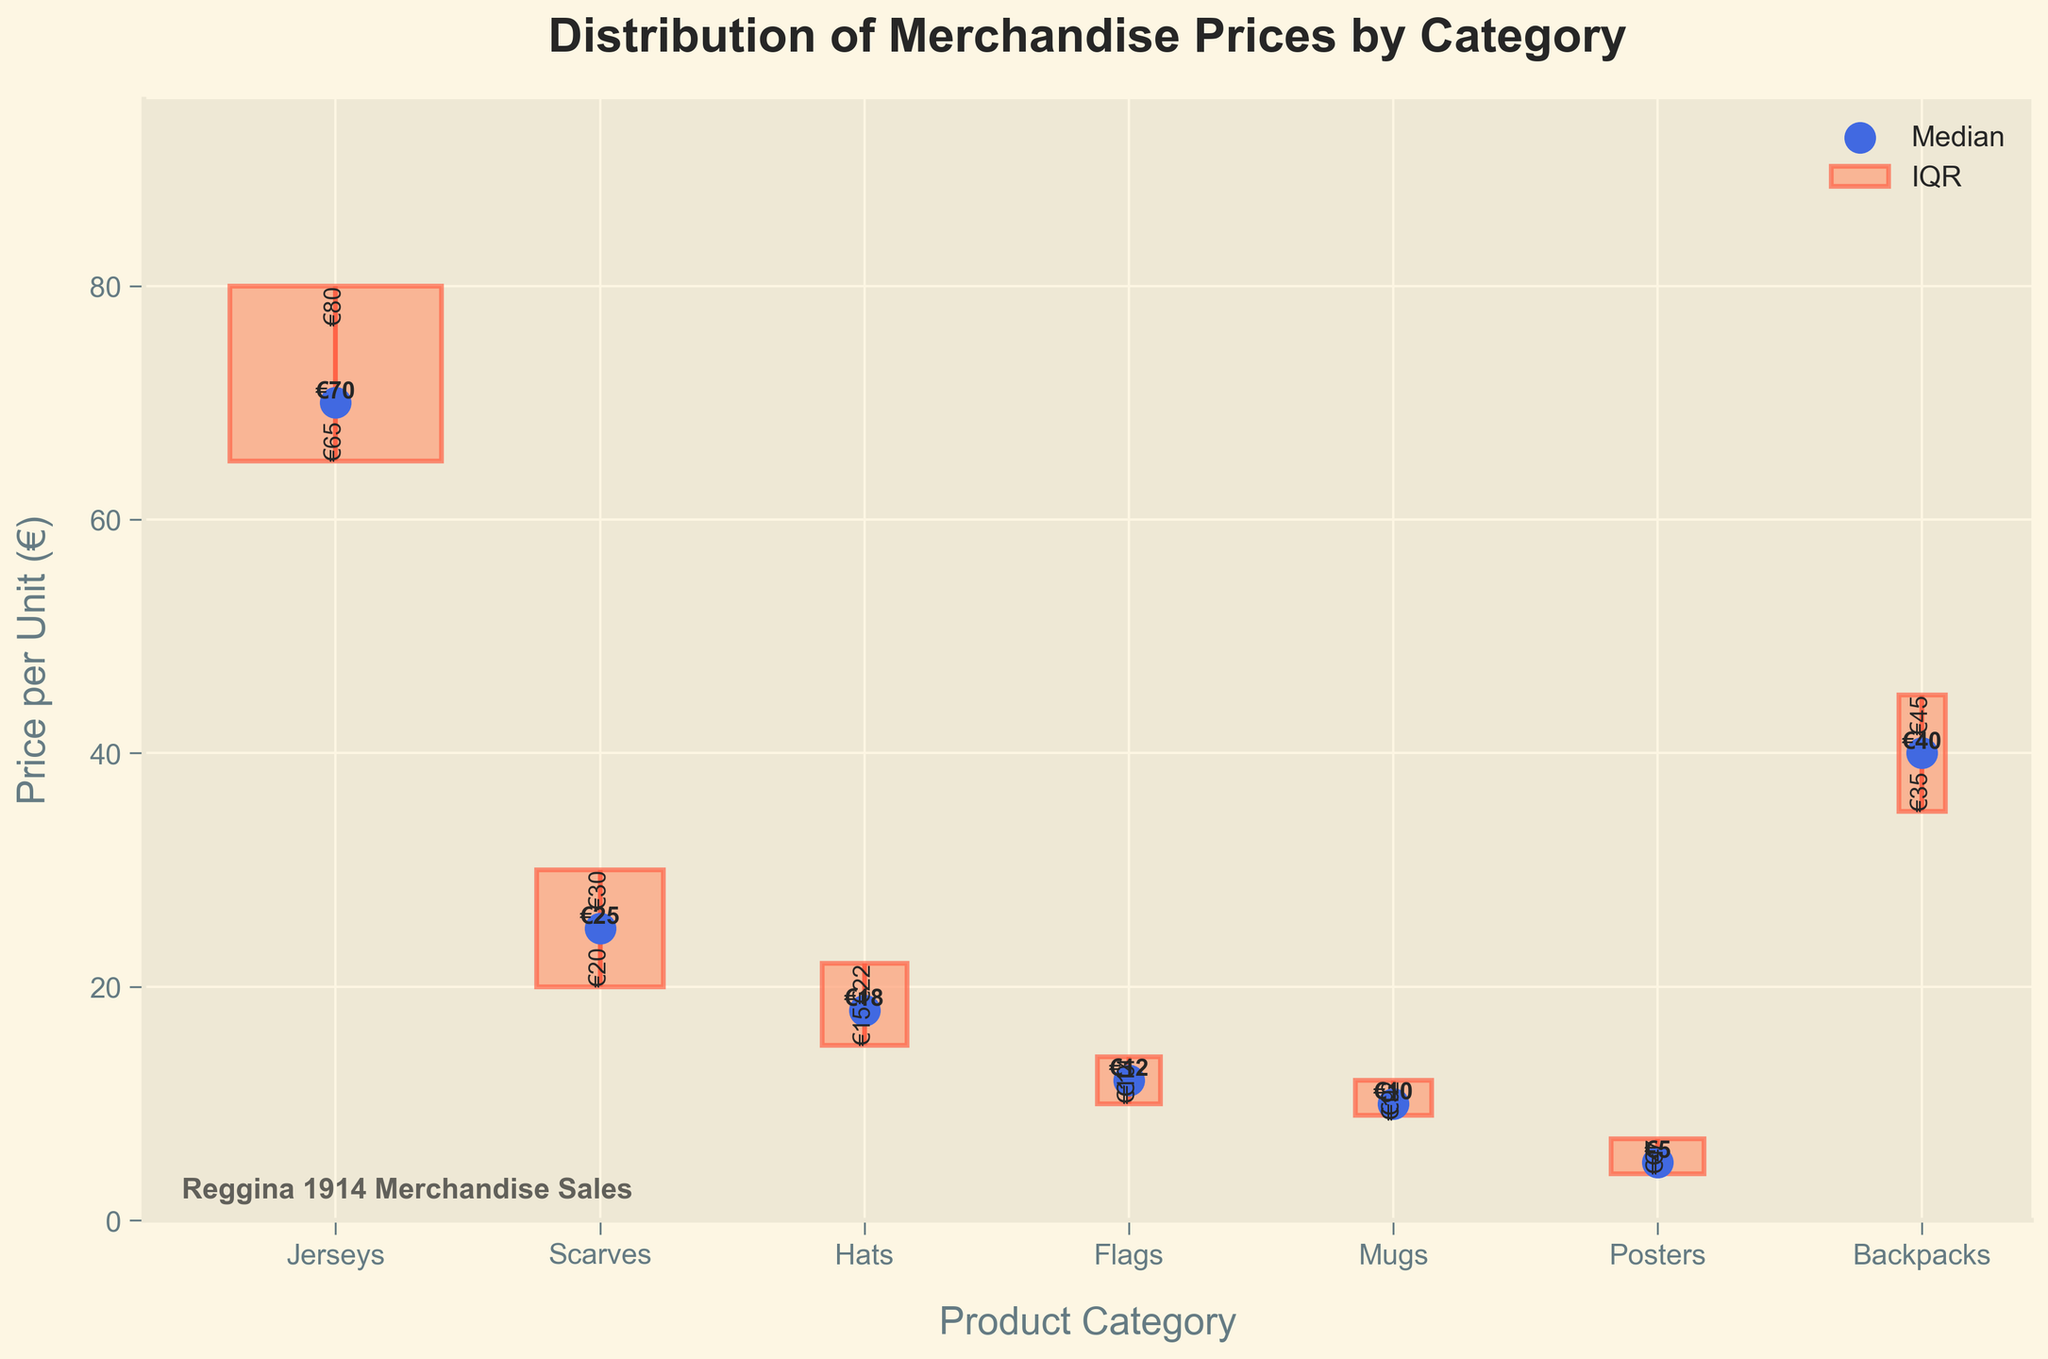What are the product categories shown in the figure? The product categories are displayed along the x-axis. By reading the labels, we can see the categories listed from left to right: Jerseys, Scarves, Hats, Flags, Mugs, Posters, and Backpacks.
Answer: Jerseys, Scarves, Hats, Flags, Mugs, Posters, Backpacks Which product category has the highest median price per unit? The figure marks the median price with blue dots. By observing the blue dots' positions, Jerseys has the highest median price at €70.
Answer: Jerseys What is the price range (IQR) for Hats? The price range for the interquartile range (IQR) is the difference between Q3 and Q1. For Hats, Q3 is €22 and Q1 is €15. The IQR is €22 - €15 = €7.
Answer: €7 How does the median price of Mugs compare to that of Posters? We compare the blue dots for both categories. The median price for Mugs is €10, while for Posters it is €5. Therefore, the median price for Mugs is higher.
Answer: Higher What is the median price for Flags? The median price is indicated by the blue dot for the Flags category. The blue dot for Flags is at €12.
Answer: €12 Among the product categories, which one has the smallest range in prices (IQR)? To find the smallest IQR, compare the lengths of the orange bars representing the IQR for each category. Flags, with a range from €10 to €14 (IQR = 4), has the smallest IQR.
Answer: Flags Which product category has the widest IQR and what is that range? The widest IQR can be detected by finding the longest orange bar. Jerseys have the widest IQR with Q1 at €65 and Q3 at €80, resulting in an IQR of €15.
Answer: Jerseys, €15 What does the width of the bars represent in the figure? The width of the bars represents the number of units sold in each product category. This is why Jerseys has the widest bar as it has the highest number of units sold, and Backpacks have the narrowest bar.
Answer: Number of units sold Compare the median prices of Scarves and Hats. Which has the lower median price? By comparing the blue dots' positions, we see that the median price for Scarves is €25 and for Hats is €18. Hats have the lower median price.
Answer: Hats Which product category has both its Q1 and Q3 values labeled closest to each other? On inspecting the orange bars and the values labeled next to them, Mugs, with Q1 at €9 and Q3 at €12, have the closest Q1 and Q3 values.
Answer: Mugs 